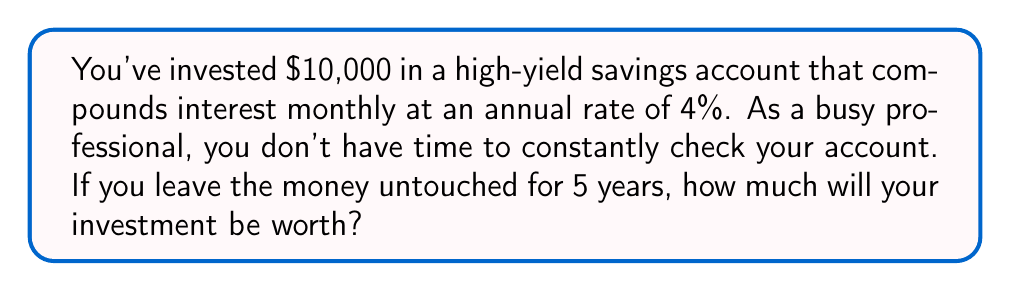Teach me how to tackle this problem. To solve this problem, we'll use the compound interest formula:

$$A = P(1 + \frac{r}{n})^{nt}$$

Where:
$A$ = Final amount
$P$ = Principal (initial investment)
$r$ = Annual interest rate (as a decimal)
$n$ = Number of times interest is compounded per year
$t$ = Number of years

Given:
$P = 10000$
$r = 0.04$ (4% expressed as a decimal)
$n = 12$ (compounded monthly)
$t = 5$ years

Let's plug these values into the formula:

$$A = 10000(1 + \frac{0.04}{12})^{12 \cdot 5}$$

$$A = 10000(1 + 0.003333...)^{60}$$

$$A = 10000(1.003333...)^{60}$$

Using a calculator or spreadsheet to compute this:

$$A = 10000 \cdot 1.2219...$$

$$A = 12219.06$$

Rounding to the nearest cent gives us the final answer.
Answer: $12,219.06 